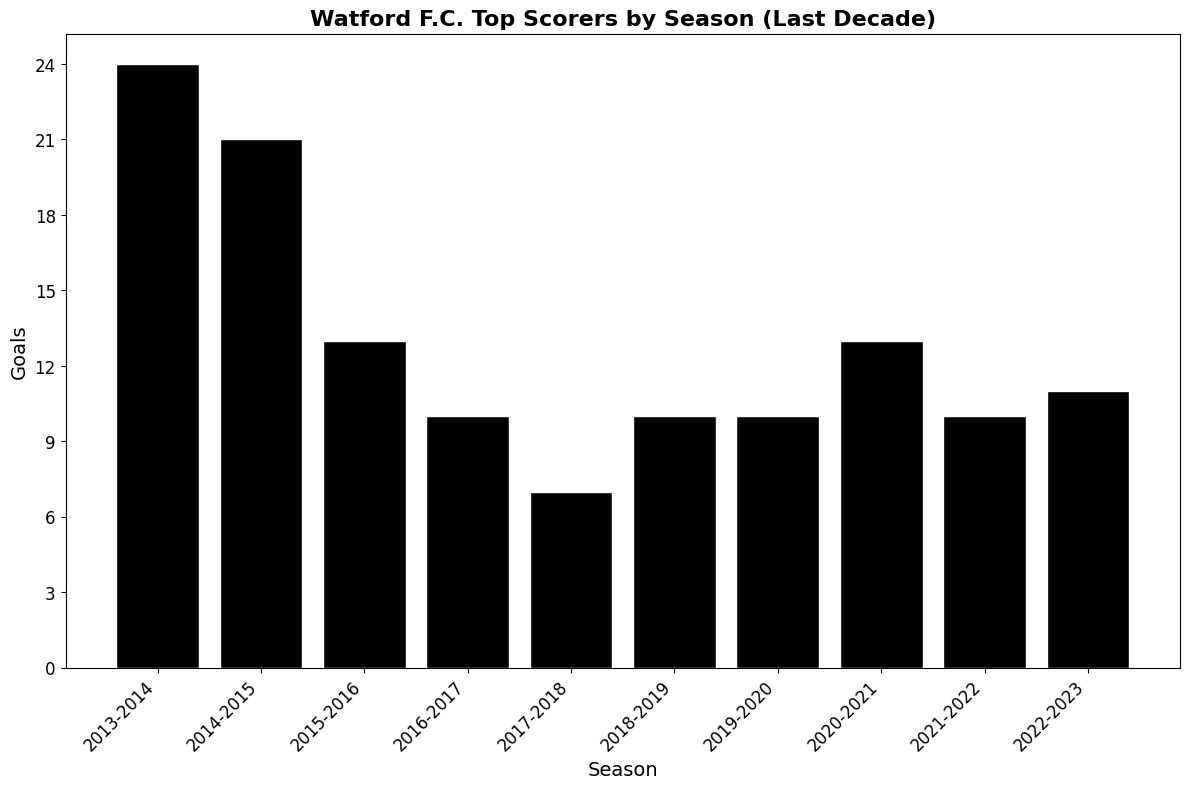Which season did Troy Deeney score the most goals? Identify all seasons in which Troy Deeney was the top scorer and compare the number of goals. The highest is in 2013-2014 with 24 goals.
Answer: 2013-2014 Who was Watford F.C.'s top scorer in the 2017-2018 season and how many goals did they score? Look at the bar corresponding to the 2017-2018 season and see Abdoulaye Doucouré scored 7 goals.
Answer: Abdoulaye Doucouré, 7 How many goals did the top scorer of the 2020-2021 season score more than the top scorer of the 2017-2018 season? Subtract the number of goals in 2017-2018 (7) from the number of goals in 2020-2021 (13).
Answer: 6 Which season had the lowest number of goals scored by the top scorer and who was it? Identify the season with the shortest bar; in this case, 2017-2018, with Abdoulaye Doucouré scoring 7 goals.
Answer: 2017-2018, Abdoulaye Doucouré In which seasons did the top scorer of Watford F.C. score exactly 10 goals? Look for bars labeled with 10 goals and identify their corresponding seasons; these are 2016-2017, 2018-2019, 2019-2020, and 2021-2022.
Answer: 2016-2017, 2018-2019, 2019-2020, 2021-2022 What is the combined total number of goals scored by the top scorers in the last three seasons? Sum the number of goals in 2020-2021 (13), 2021-2022 (10), and 2022-2023 (11). The total is 34 goals.
Answer: 34 Who had more goals, Ismaïla Sarr in the 2020-2021 season or João Pedro in the 2022-2023 season? Compare the number of goals in 2020-2021 (Ismaïla Sarr, 13) and 2022-2023 (João Pedro, 11).
Answer: Ismaïla Sarr Between the seasons 2014-2015 and 2015-2016, how many differences are there in goals scored by the top scorers? Subtract the goals in 2015-2016 (13) from the goals in 2014-2015 (21). The difference is 8 goals.
Answer: 8 Calculate the average number of goals scored by the top scorers across all seasons. Sum all the goals (24 + 21 + 13 + 10 + 7 + 10 + 10 + 13 + 10 + 11) which equals 129 and divide by the number of seasons (10). The average is 12.9.
Answer: 12.9 How many different players have been Watford F.C.'s top scorers in the last decade? Identify unique names in the "Top Scorer" column: Troy Deeney, Abdoulaye Doucouré, Gerard Deulofeu, Ismaïla Sarr, Emmanuel Dennis, and João Pedro. There are 6 unique players.
Answer: 6 